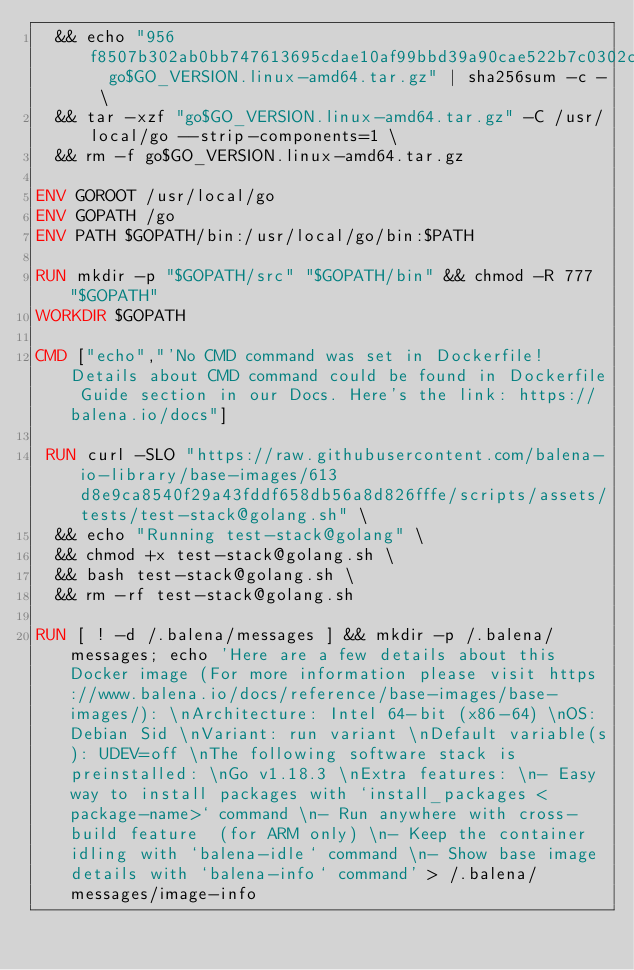Convert code to text. <code><loc_0><loc_0><loc_500><loc_500><_Dockerfile_>	&& echo "956f8507b302ab0bb747613695cdae10af99bbd39a90cae522b7c0302cc27245  go$GO_VERSION.linux-amd64.tar.gz" | sha256sum -c - \
	&& tar -xzf "go$GO_VERSION.linux-amd64.tar.gz" -C /usr/local/go --strip-components=1 \
	&& rm -f go$GO_VERSION.linux-amd64.tar.gz

ENV GOROOT /usr/local/go
ENV GOPATH /go
ENV PATH $GOPATH/bin:/usr/local/go/bin:$PATH

RUN mkdir -p "$GOPATH/src" "$GOPATH/bin" && chmod -R 777 "$GOPATH"
WORKDIR $GOPATH

CMD ["echo","'No CMD command was set in Dockerfile! Details about CMD command could be found in Dockerfile Guide section in our Docs. Here's the link: https://balena.io/docs"]

 RUN curl -SLO "https://raw.githubusercontent.com/balena-io-library/base-images/613d8e9ca8540f29a43fddf658db56a8d826fffe/scripts/assets/tests/test-stack@golang.sh" \
  && echo "Running test-stack@golang" \
  && chmod +x test-stack@golang.sh \
  && bash test-stack@golang.sh \
  && rm -rf test-stack@golang.sh 

RUN [ ! -d /.balena/messages ] && mkdir -p /.balena/messages; echo 'Here are a few details about this Docker image (For more information please visit https://www.balena.io/docs/reference/base-images/base-images/): \nArchitecture: Intel 64-bit (x86-64) \nOS: Debian Sid \nVariant: run variant \nDefault variable(s): UDEV=off \nThe following software stack is preinstalled: \nGo v1.18.3 \nExtra features: \n- Easy way to install packages with `install_packages <package-name>` command \n- Run anywhere with cross-build feature  (for ARM only) \n- Keep the container idling with `balena-idle` command \n- Show base image details with `balena-info` command' > /.balena/messages/image-info</code> 